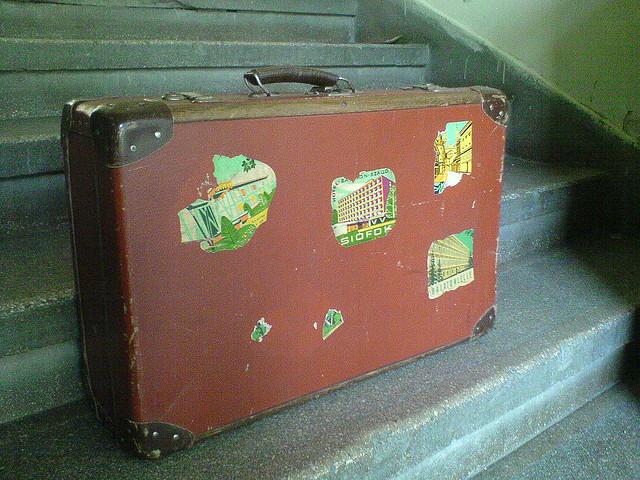What is all over the suitcase?
Write a very short answer. Stickers. Is this a new suitcase?
Write a very short answer. No. How old are the steps?
Quick response, please. Very old. 